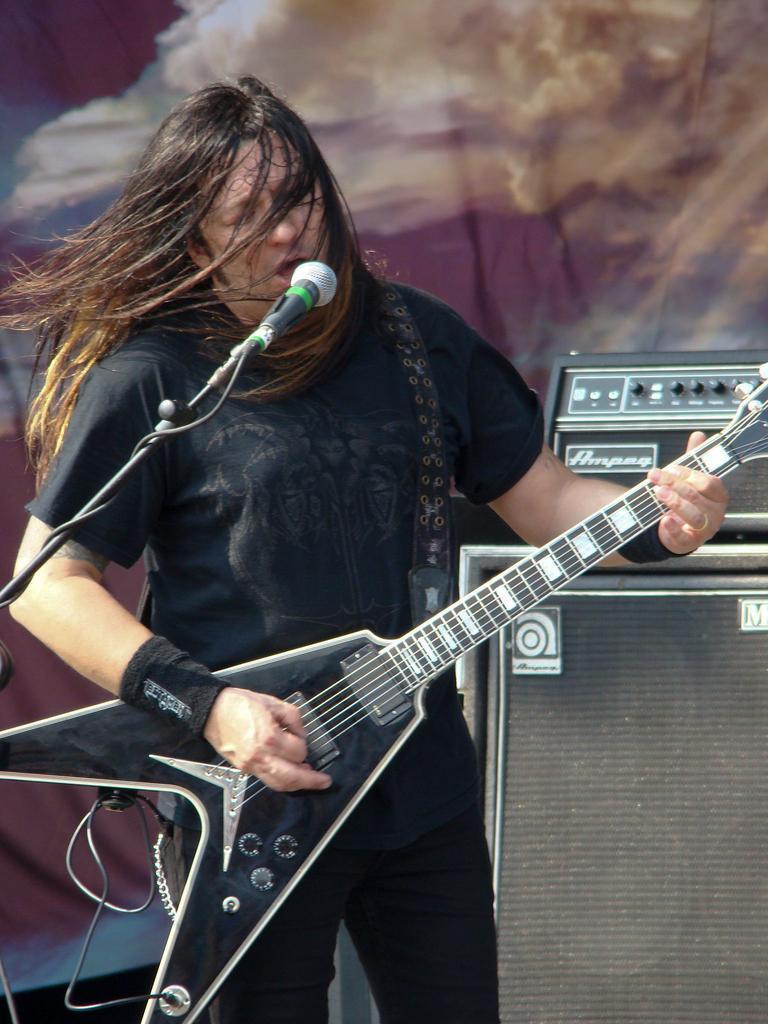Could you give a brief overview of what you see in this image? In this image we can see a person standing and playing a guitar, in front of him there is a microphone and behind him there are objects which looks like a speaker. 